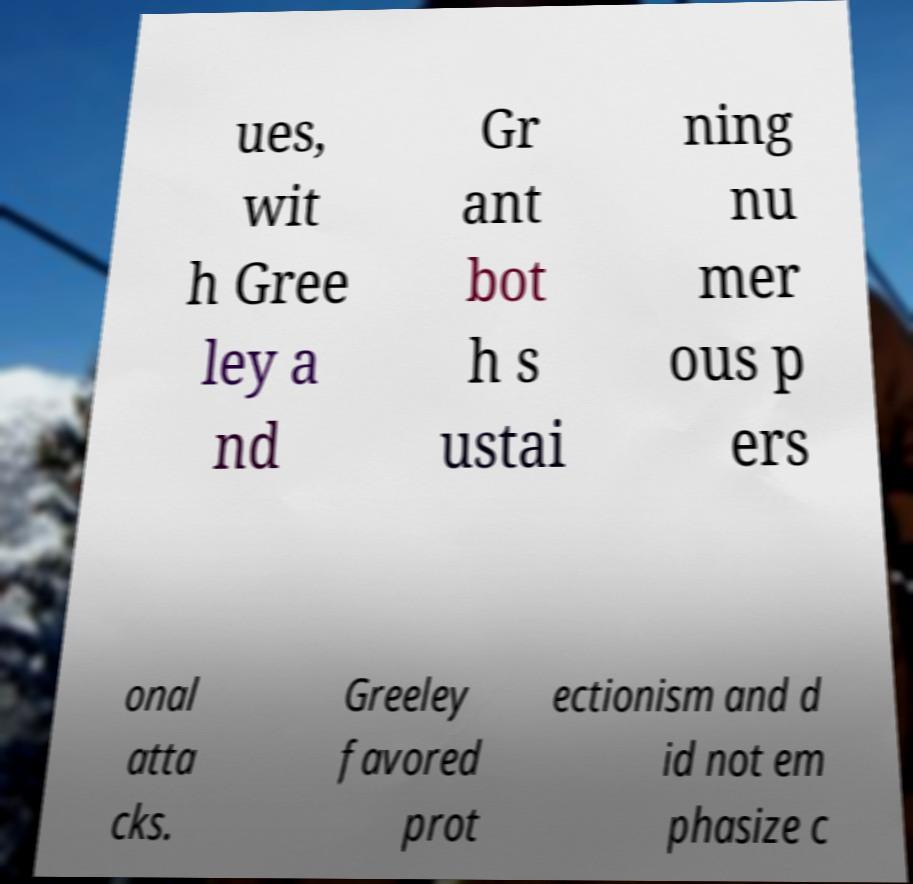Could you extract and type out the text from this image? ues, wit h Gree ley a nd Gr ant bot h s ustai ning nu mer ous p ers onal atta cks. Greeley favored prot ectionism and d id not em phasize c 